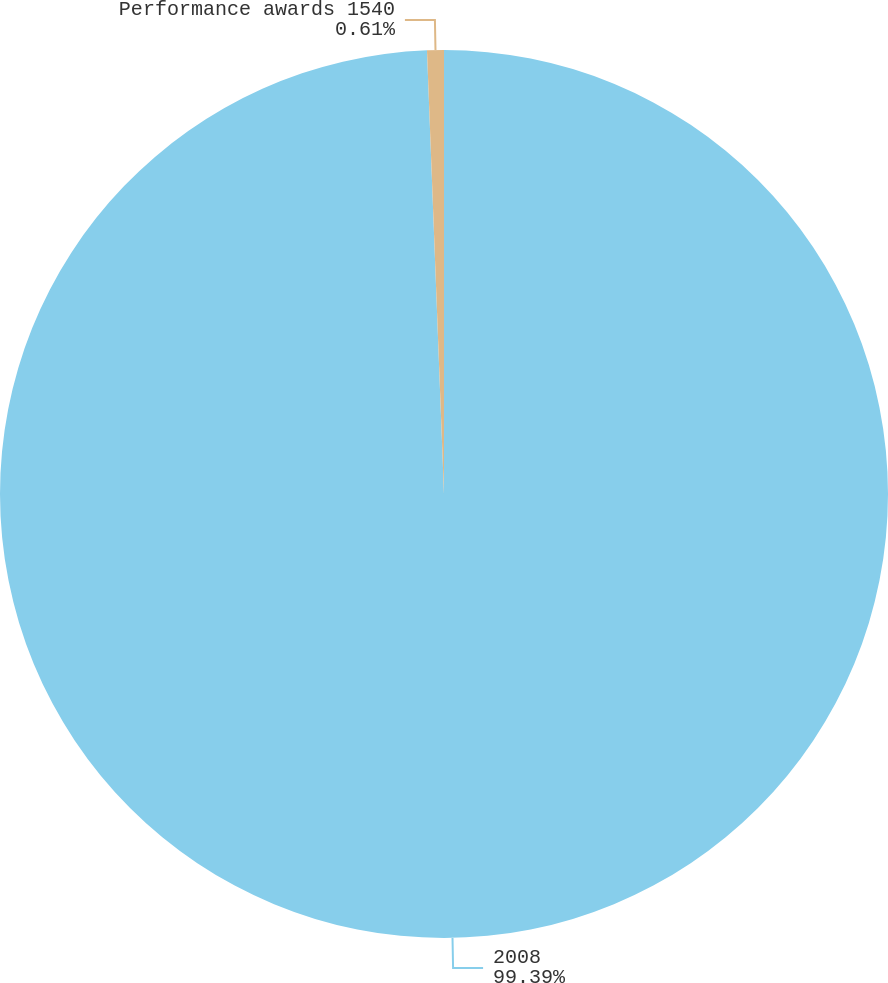Convert chart to OTSL. <chart><loc_0><loc_0><loc_500><loc_500><pie_chart><fcel>2008<fcel>Performance awards 1540<nl><fcel>99.39%<fcel>0.61%<nl></chart> 